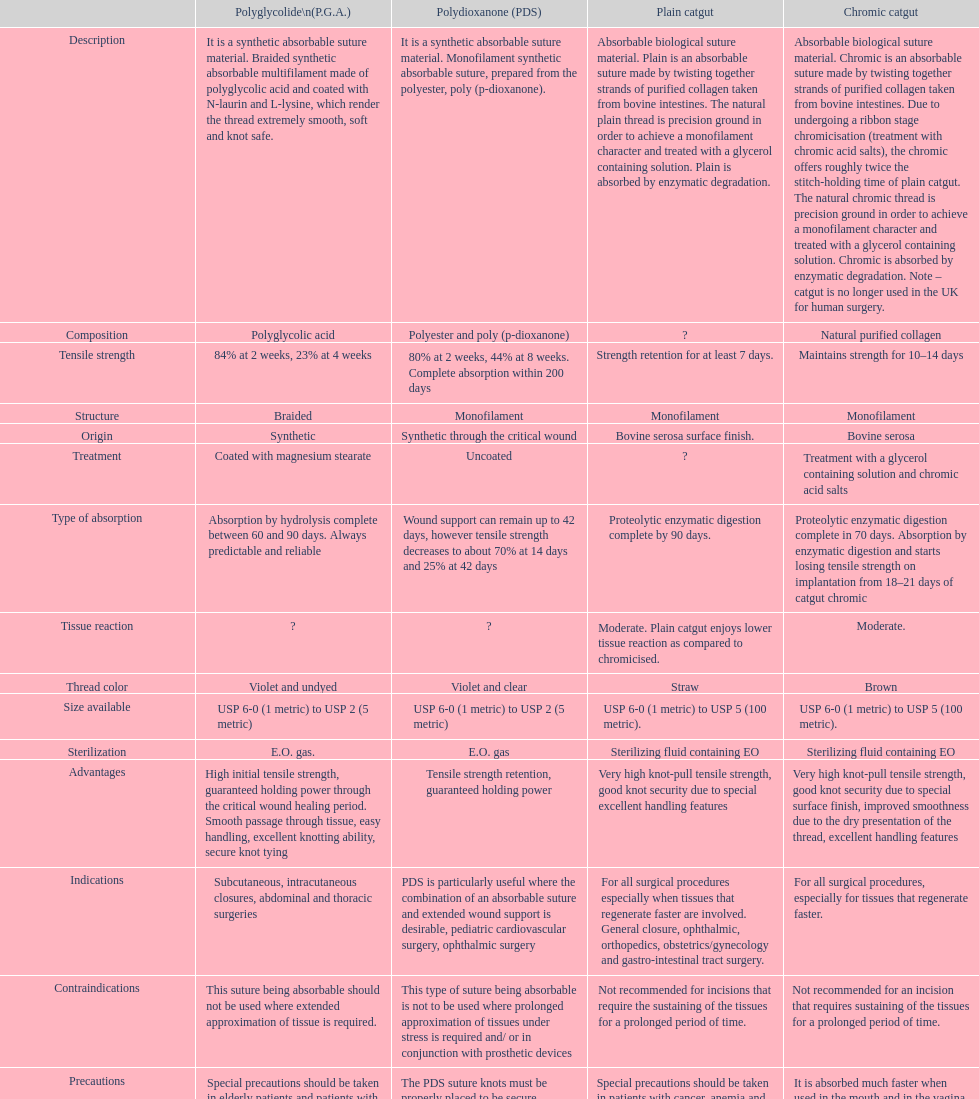What is the entire sum of suture materials featuring a mono-filament configuration? 3. 